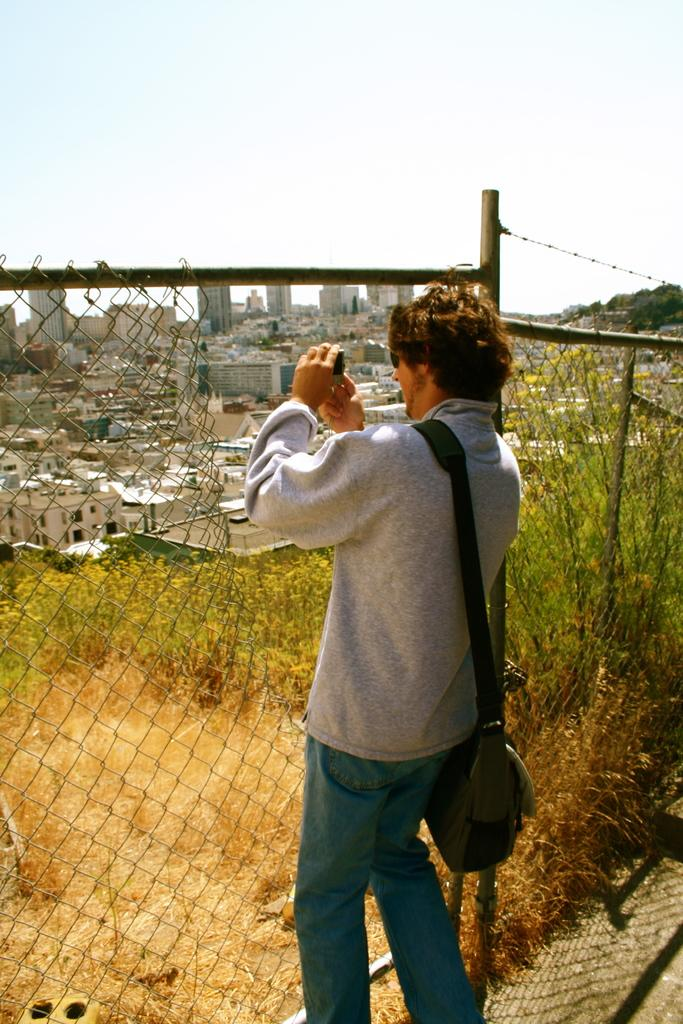What is the man in the image doing? The man is standing in the image. What is the man holding in the image? The man is holding an object. What can be seen in the background of the image? There are trees, buildings, and the sky visible in the background of the image. What type of natural elements are present in the image? There are plants and trees in the image. What type of man-made structure can be seen in the image? There is a fence in the image. How many wings can be seen on the man in the image? There are no wings visible on the man in the image. What type of ear is the man wearing in the image? The man is not wearing any ear in the image. 